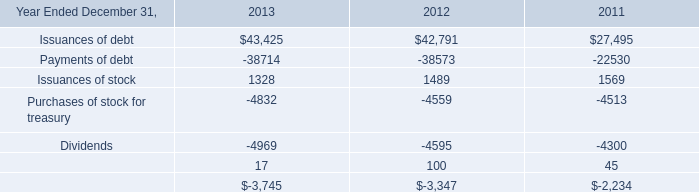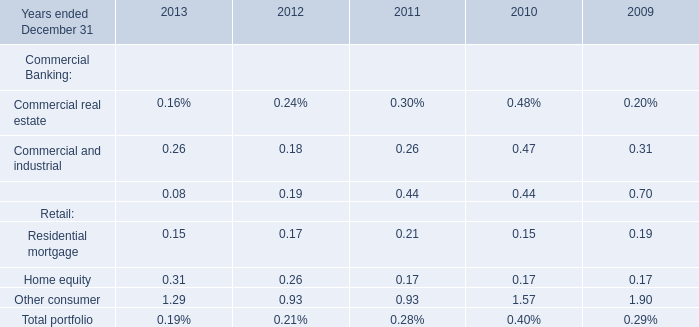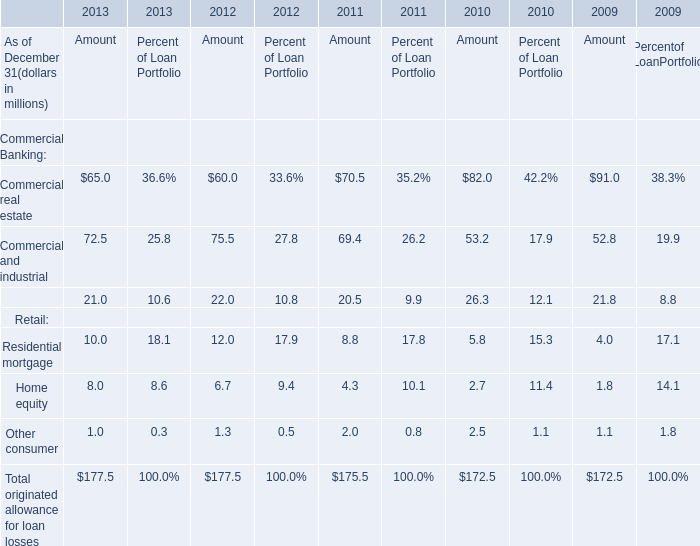What do all elements sum up in 2012, excluding Commercial real estate and Commercial and industrial? (in million) 
Computations: (((22 + 12) + 6.7) + 1.3)
Answer: 42.0. 